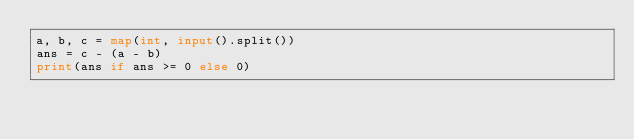<code> <loc_0><loc_0><loc_500><loc_500><_Python_>a, b, c = map(int, input().split())
ans = c - (a - b)
print(ans if ans >= 0 else 0)
</code> 